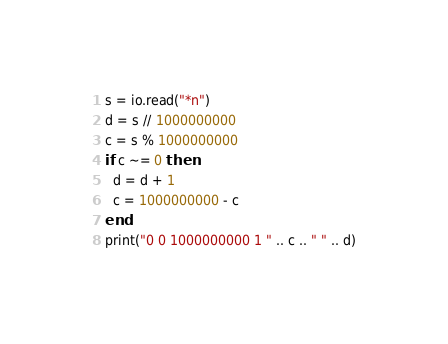Convert code to text. <code><loc_0><loc_0><loc_500><loc_500><_Lua_>s = io.read("*n")
d = s // 1000000000
c = s % 1000000000
if c ~= 0 then
  d = d + 1
  c = 1000000000 - c
end
print("0 0 1000000000 1 " .. c .. " " .. d)
</code> 